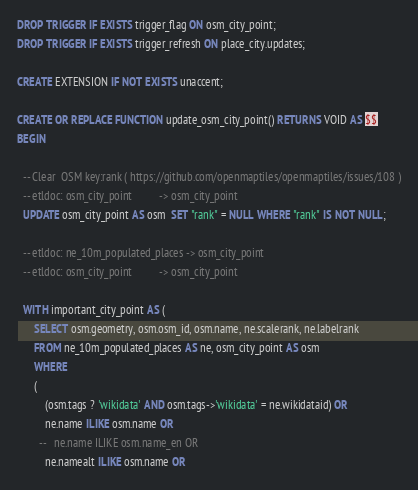Convert code to text. <code><loc_0><loc_0><loc_500><loc_500><_SQL_>DROP TRIGGER IF EXISTS trigger_flag ON osm_city_point;
DROP TRIGGER IF EXISTS trigger_refresh ON place_city.updates;

CREATE EXTENSION IF NOT EXISTS unaccent;

CREATE OR REPLACE FUNCTION update_osm_city_point() RETURNS VOID AS $$
BEGIN

  -- Clear  OSM key:rank ( https://github.com/openmaptiles/openmaptiles/issues/108 )
  -- etldoc: osm_city_point          -> osm_city_point
  UPDATE osm_city_point AS osm  SET "rank" = NULL WHERE "rank" IS NOT NULL;

  -- etldoc: ne_10m_populated_places -> osm_city_point
  -- etldoc: osm_city_point          -> osm_city_point

  WITH important_city_point AS (
      SELECT osm.geometry, osm.osm_id, osm.name, ne.scalerank, ne.labelrank
      FROM ne_10m_populated_places AS ne, osm_city_point AS osm
      WHERE
      (
          (osm.tags ? 'wikidata' AND osm.tags->'wikidata' = ne.wikidataid) OR
          ne.name ILIKE osm.name OR
        --   ne.name ILIKE osm.name_en OR
          ne.namealt ILIKE osm.name OR</code> 